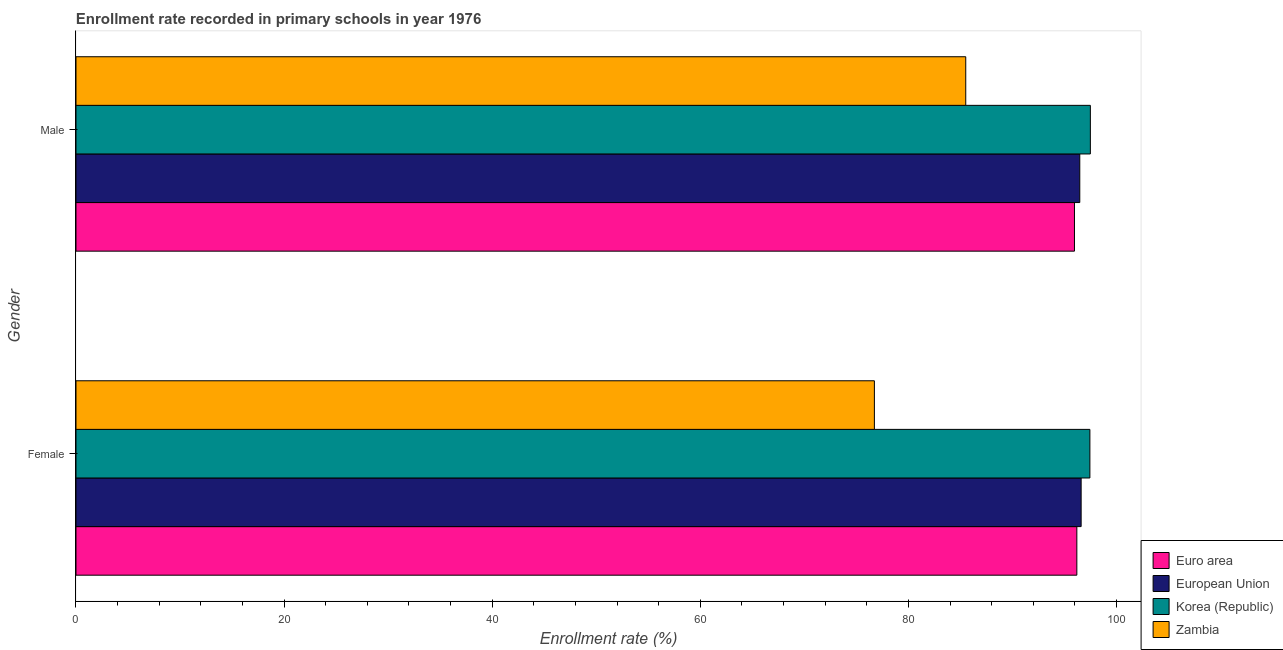How many different coloured bars are there?
Your answer should be compact. 4. Are the number of bars per tick equal to the number of legend labels?
Make the answer very short. Yes. Are the number of bars on each tick of the Y-axis equal?
Provide a short and direct response. Yes. How many bars are there on the 2nd tick from the bottom?
Provide a short and direct response. 4. What is the enrollment rate of male students in Euro area?
Provide a short and direct response. 95.96. Across all countries, what is the maximum enrollment rate of male students?
Provide a short and direct response. 97.49. Across all countries, what is the minimum enrollment rate of female students?
Provide a short and direct response. 76.73. In which country was the enrollment rate of male students maximum?
Ensure brevity in your answer.  Korea (Republic). In which country was the enrollment rate of female students minimum?
Your response must be concise. Zambia. What is the total enrollment rate of female students in the graph?
Ensure brevity in your answer.  366.96. What is the difference between the enrollment rate of female students in European Union and that in Zambia?
Keep it short and to the point. 19.87. What is the difference between the enrollment rate of female students in Zambia and the enrollment rate of male students in Korea (Republic)?
Provide a succinct answer. -20.76. What is the average enrollment rate of female students per country?
Your answer should be compact. 91.74. What is the difference between the enrollment rate of male students and enrollment rate of female students in European Union?
Keep it short and to the point. -0.13. In how many countries, is the enrollment rate of female students greater than 76 %?
Your answer should be compact. 4. What is the ratio of the enrollment rate of male students in Korea (Republic) to that in Zambia?
Keep it short and to the point. 1.14. What does the 2nd bar from the top in Male represents?
Make the answer very short. Korea (Republic). What does the 1st bar from the bottom in Female represents?
Offer a very short reply. Euro area. How many countries are there in the graph?
Give a very brief answer. 4. Does the graph contain any zero values?
Keep it short and to the point. No. Does the graph contain grids?
Provide a succinct answer. No. What is the title of the graph?
Your answer should be very brief. Enrollment rate recorded in primary schools in year 1976. What is the label or title of the X-axis?
Offer a very short reply. Enrollment rate (%). What is the Enrollment rate (%) of Euro area in Female?
Provide a short and direct response. 96.19. What is the Enrollment rate (%) of European Union in Female?
Provide a short and direct response. 96.6. What is the Enrollment rate (%) in Korea (Republic) in Female?
Offer a very short reply. 97.44. What is the Enrollment rate (%) of Zambia in Female?
Offer a terse response. 76.73. What is the Enrollment rate (%) of Euro area in Male?
Your answer should be very brief. 95.96. What is the Enrollment rate (%) in European Union in Male?
Keep it short and to the point. 96.47. What is the Enrollment rate (%) of Korea (Republic) in Male?
Provide a succinct answer. 97.49. What is the Enrollment rate (%) of Zambia in Male?
Provide a short and direct response. 85.51. Across all Gender, what is the maximum Enrollment rate (%) in Euro area?
Give a very brief answer. 96.19. Across all Gender, what is the maximum Enrollment rate (%) of European Union?
Your answer should be compact. 96.6. Across all Gender, what is the maximum Enrollment rate (%) of Korea (Republic)?
Provide a succinct answer. 97.49. Across all Gender, what is the maximum Enrollment rate (%) in Zambia?
Your response must be concise. 85.51. Across all Gender, what is the minimum Enrollment rate (%) in Euro area?
Your answer should be compact. 95.96. Across all Gender, what is the minimum Enrollment rate (%) of European Union?
Your response must be concise. 96.47. Across all Gender, what is the minimum Enrollment rate (%) in Korea (Republic)?
Provide a short and direct response. 97.44. Across all Gender, what is the minimum Enrollment rate (%) of Zambia?
Your answer should be very brief. 76.73. What is the total Enrollment rate (%) in Euro area in the graph?
Ensure brevity in your answer.  192.15. What is the total Enrollment rate (%) of European Union in the graph?
Your answer should be very brief. 193.07. What is the total Enrollment rate (%) of Korea (Republic) in the graph?
Provide a short and direct response. 194.93. What is the total Enrollment rate (%) of Zambia in the graph?
Offer a very short reply. 162.24. What is the difference between the Enrollment rate (%) in Euro area in Female and that in Male?
Offer a very short reply. 0.23. What is the difference between the Enrollment rate (%) in European Union in Female and that in Male?
Give a very brief answer. 0.13. What is the difference between the Enrollment rate (%) of Korea (Republic) in Female and that in Male?
Provide a succinct answer. -0.05. What is the difference between the Enrollment rate (%) of Zambia in Female and that in Male?
Keep it short and to the point. -8.78. What is the difference between the Enrollment rate (%) in Euro area in Female and the Enrollment rate (%) in European Union in Male?
Keep it short and to the point. -0.28. What is the difference between the Enrollment rate (%) of Euro area in Female and the Enrollment rate (%) of Korea (Republic) in Male?
Make the answer very short. -1.3. What is the difference between the Enrollment rate (%) in Euro area in Female and the Enrollment rate (%) in Zambia in Male?
Make the answer very short. 10.68. What is the difference between the Enrollment rate (%) of European Union in Female and the Enrollment rate (%) of Korea (Republic) in Male?
Provide a short and direct response. -0.89. What is the difference between the Enrollment rate (%) of European Union in Female and the Enrollment rate (%) of Zambia in Male?
Make the answer very short. 11.09. What is the difference between the Enrollment rate (%) in Korea (Republic) in Female and the Enrollment rate (%) in Zambia in Male?
Make the answer very short. 11.93. What is the average Enrollment rate (%) in Euro area per Gender?
Offer a terse response. 96.07. What is the average Enrollment rate (%) of European Union per Gender?
Your answer should be very brief. 96.54. What is the average Enrollment rate (%) in Korea (Republic) per Gender?
Your response must be concise. 97.47. What is the average Enrollment rate (%) in Zambia per Gender?
Keep it short and to the point. 81.12. What is the difference between the Enrollment rate (%) of Euro area and Enrollment rate (%) of European Union in Female?
Your answer should be compact. -0.41. What is the difference between the Enrollment rate (%) in Euro area and Enrollment rate (%) in Korea (Republic) in Female?
Your answer should be very brief. -1.25. What is the difference between the Enrollment rate (%) of Euro area and Enrollment rate (%) of Zambia in Female?
Your answer should be compact. 19.46. What is the difference between the Enrollment rate (%) in European Union and Enrollment rate (%) in Korea (Republic) in Female?
Provide a short and direct response. -0.84. What is the difference between the Enrollment rate (%) in European Union and Enrollment rate (%) in Zambia in Female?
Offer a terse response. 19.87. What is the difference between the Enrollment rate (%) of Korea (Republic) and Enrollment rate (%) of Zambia in Female?
Your response must be concise. 20.71. What is the difference between the Enrollment rate (%) of Euro area and Enrollment rate (%) of European Union in Male?
Give a very brief answer. -0.51. What is the difference between the Enrollment rate (%) in Euro area and Enrollment rate (%) in Korea (Republic) in Male?
Make the answer very short. -1.53. What is the difference between the Enrollment rate (%) in Euro area and Enrollment rate (%) in Zambia in Male?
Make the answer very short. 10.45. What is the difference between the Enrollment rate (%) of European Union and Enrollment rate (%) of Korea (Republic) in Male?
Offer a very short reply. -1.02. What is the difference between the Enrollment rate (%) in European Union and Enrollment rate (%) in Zambia in Male?
Provide a short and direct response. 10.96. What is the difference between the Enrollment rate (%) of Korea (Republic) and Enrollment rate (%) of Zambia in Male?
Your answer should be compact. 11.98. What is the ratio of the Enrollment rate (%) of European Union in Female to that in Male?
Your answer should be very brief. 1. What is the ratio of the Enrollment rate (%) of Korea (Republic) in Female to that in Male?
Provide a short and direct response. 1. What is the ratio of the Enrollment rate (%) in Zambia in Female to that in Male?
Make the answer very short. 0.9. What is the difference between the highest and the second highest Enrollment rate (%) of Euro area?
Your answer should be compact. 0.23. What is the difference between the highest and the second highest Enrollment rate (%) in European Union?
Your answer should be very brief. 0.13. What is the difference between the highest and the second highest Enrollment rate (%) in Korea (Republic)?
Keep it short and to the point. 0.05. What is the difference between the highest and the second highest Enrollment rate (%) of Zambia?
Offer a very short reply. 8.78. What is the difference between the highest and the lowest Enrollment rate (%) of Euro area?
Offer a very short reply. 0.23. What is the difference between the highest and the lowest Enrollment rate (%) in European Union?
Make the answer very short. 0.13. What is the difference between the highest and the lowest Enrollment rate (%) of Korea (Republic)?
Give a very brief answer. 0.05. What is the difference between the highest and the lowest Enrollment rate (%) of Zambia?
Ensure brevity in your answer.  8.78. 